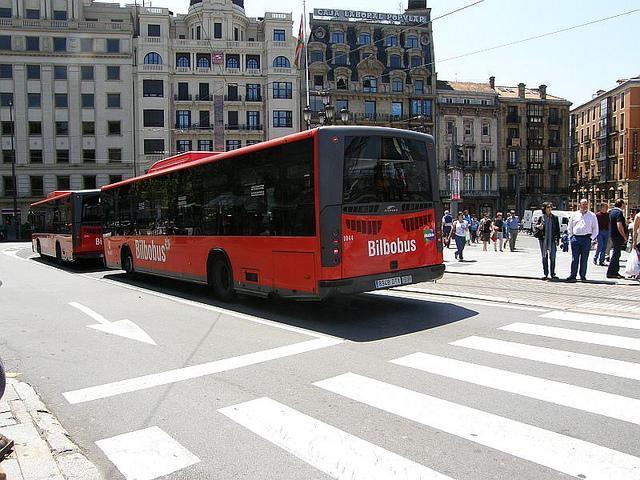How many buses are there?
Give a very brief answer. 2. How many forks are on the table?
Give a very brief answer. 0. 